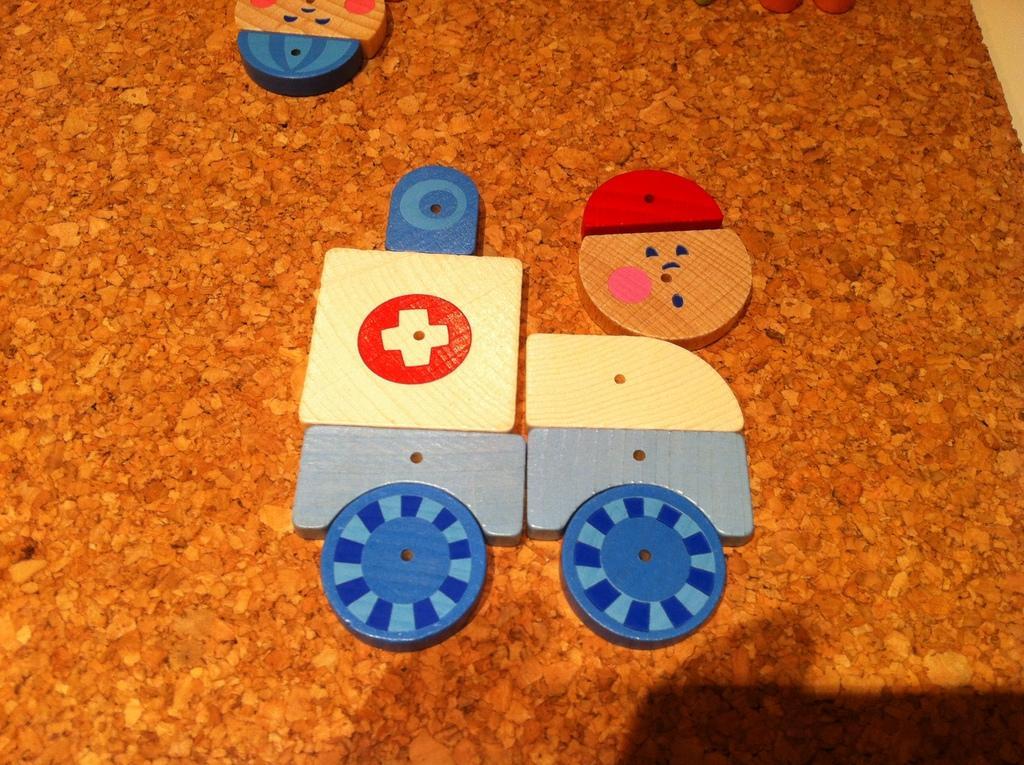Describe this image in one or two sentences. On a brown surface there is a toy vehicle made with blocks. 